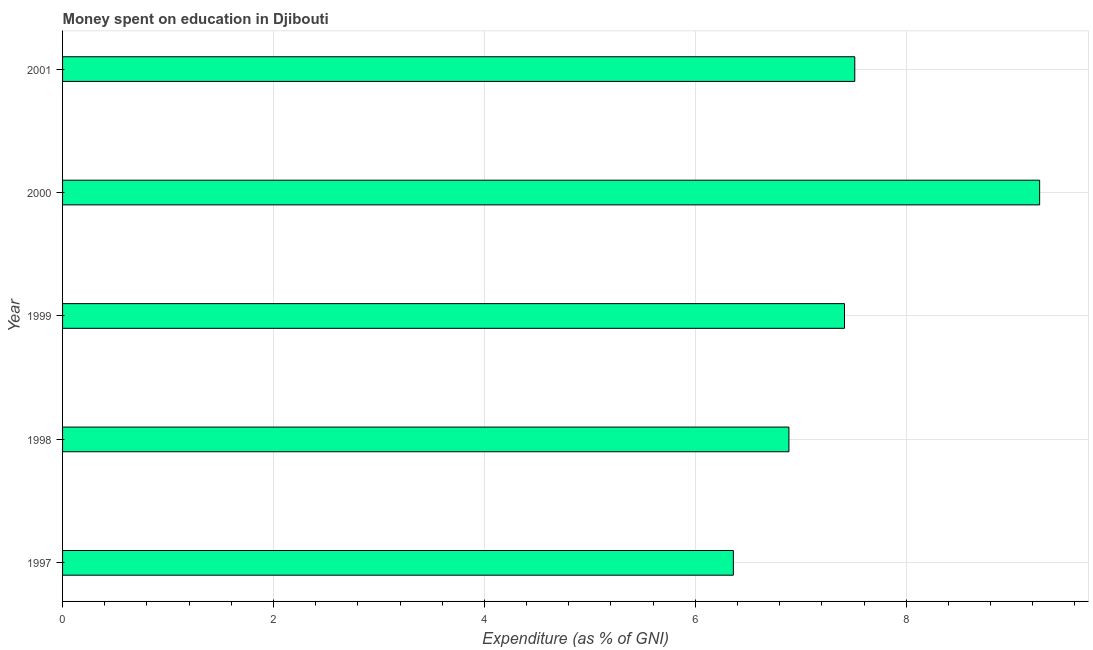What is the title of the graph?
Offer a terse response. Money spent on education in Djibouti. What is the label or title of the X-axis?
Offer a terse response. Expenditure (as % of GNI). What is the label or title of the Y-axis?
Give a very brief answer. Year. What is the expenditure on education in 2001?
Make the answer very short. 7.51. Across all years, what is the maximum expenditure on education?
Your response must be concise. 9.27. Across all years, what is the minimum expenditure on education?
Make the answer very short. 6.36. In which year was the expenditure on education maximum?
Your response must be concise. 2000. What is the sum of the expenditure on education?
Your response must be concise. 37.44. What is the difference between the expenditure on education in 1997 and 1999?
Your answer should be compact. -1.05. What is the average expenditure on education per year?
Provide a short and direct response. 7.49. What is the median expenditure on education?
Your response must be concise. 7.41. In how many years, is the expenditure on education greater than 5.6 %?
Provide a short and direct response. 5. Is the expenditure on education in 1999 less than that in 2000?
Your response must be concise. Yes. Is the difference between the expenditure on education in 1997 and 2000 greater than the difference between any two years?
Your answer should be very brief. Yes. What is the difference between the highest and the second highest expenditure on education?
Keep it short and to the point. 1.75. What is the difference between the highest and the lowest expenditure on education?
Offer a very short reply. 2.9. How many bars are there?
Your answer should be very brief. 5. Are all the bars in the graph horizontal?
Offer a very short reply. Yes. What is the Expenditure (as % of GNI) of 1997?
Ensure brevity in your answer.  6.36. What is the Expenditure (as % of GNI) in 1998?
Offer a terse response. 6.89. What is the Expenditure (as % of GNI) of 1999?
Offer a terse response. 7.41. What is the Expenditure (as % of GNI) in 2000?
Give a very brief answer. 9.27. What is the Expenditure (as % of GNI) of 2001?
Provide a short and direct response. 7.51. What is the difference between the Expenditure (as % of GNI) in 1997 and 1998?
Make the answer very short. -0.53. What is the difference between the Expenditure (as % of GNI) in 1997 and 1999?
Your answer should be very brief. -1.05. What is the difference between the Expenditure (as % of GNI) in 1997 and 2000?
Offer a very short reply. -2.9. What is the difference between the Expenditure (as % of GNI) in 1997 and 2001?
Give a very brief answer. -1.15. What is the difference between the Expenditure (as % of GNI) in 1998 and 1999?
Provide a short and direct response. -0.53. What is the difference between the Expenditure (as % of GNI) in 1998 and 2000?
Your answer should be compact. -2.38. What is the difference between the Expenditure (as % of GNI) in 1998 and 2001?
Your response must be concise. -0.62. What is the difference between the Expenditure (as % of GNI) in 1999 and 2000?
Ensure brevity in your answer.  -1.85. What is the difference between the Expenditure (as % of GNI) in 1999 and 2001?
Ensure brevity in your answer.  -0.1. What is the difference between the Expenditure (as % of GNI) in 2000 and 2001?
Make the answer very short. 1.75. What is the ratio of the Expenditure (as % of GNI) in 1997 to that in 1998?
Give a very brief answer. 0.92. What is the ratio of the Expenditure (as % of GNI) in 1997 to that in 1999?
Give a very brief answer. 0.86. What is the ratio of the Expenditure (as % of GNI) in 1997 to that in 2000?
Your answer should be compact. 0.69. What is the ratio of the Expenditure (as % of GNI) in 1997 to that in 2001?
Ensure brevity in your answer.  0.85. What is the ratio of the Expenditure (as % of GNI) in 1998 to that in 1999?
Give a very brief answer. 0.93. What is the ratio of the Expenditure (as % of GNI) in 1998 to that in 2000?
Your answer should be compact. 0.74. What is the ratio of the Expenditure (as % of GNI) in 1998 to that in 2001?
Offer a very short reply. 0.92. What is the ratio of the Expenditure (as % of GNI) in 1999 to that in 2000?
Make the answer very short. 0.8. What is the ratio of the Expenditure (as % of GNI) in 1999 to that in 2001?
Provide a succinct answer. 0.99. What is the ratio of the Expenditure (as % of GNI) in 2000 to that in 2001?
Keep it short and to the point. 1.23. 